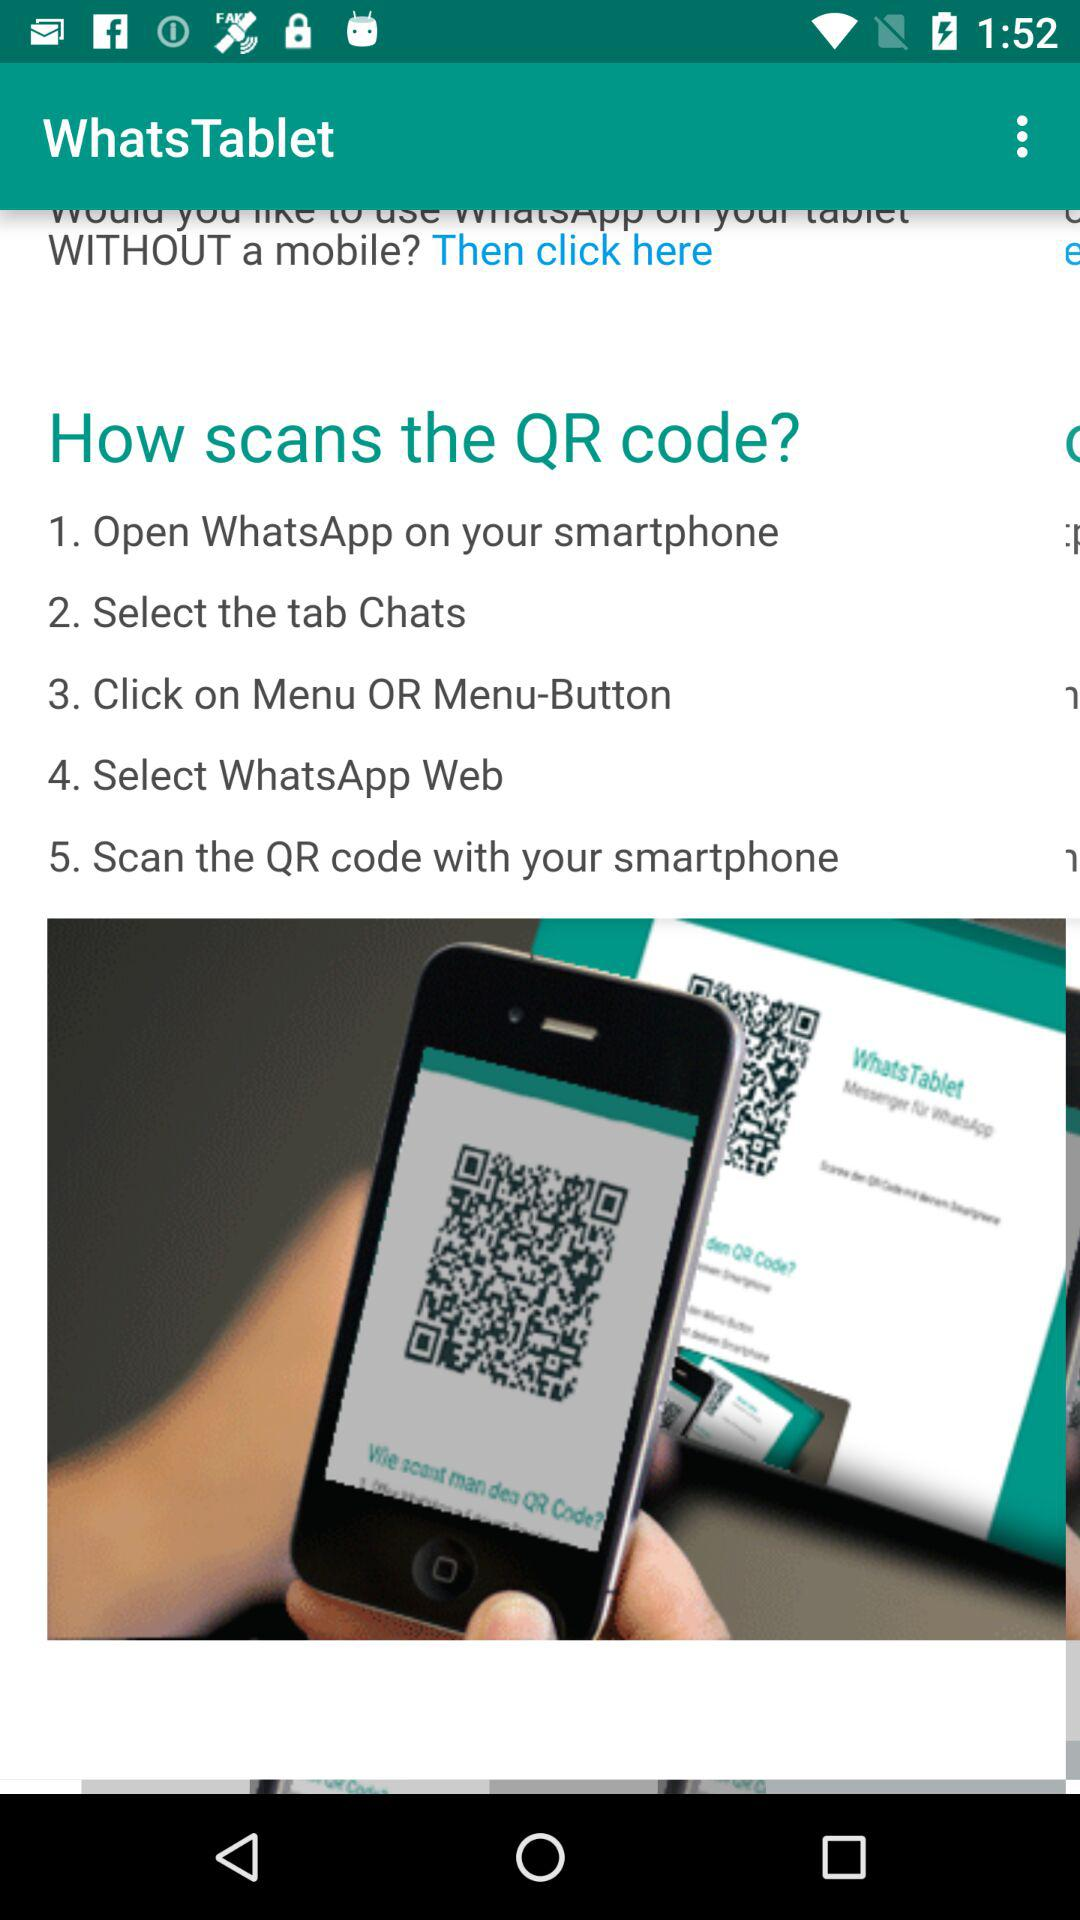What is the user's name?
When the provided information is insufficient, respond with <no answer>. <no answer> 